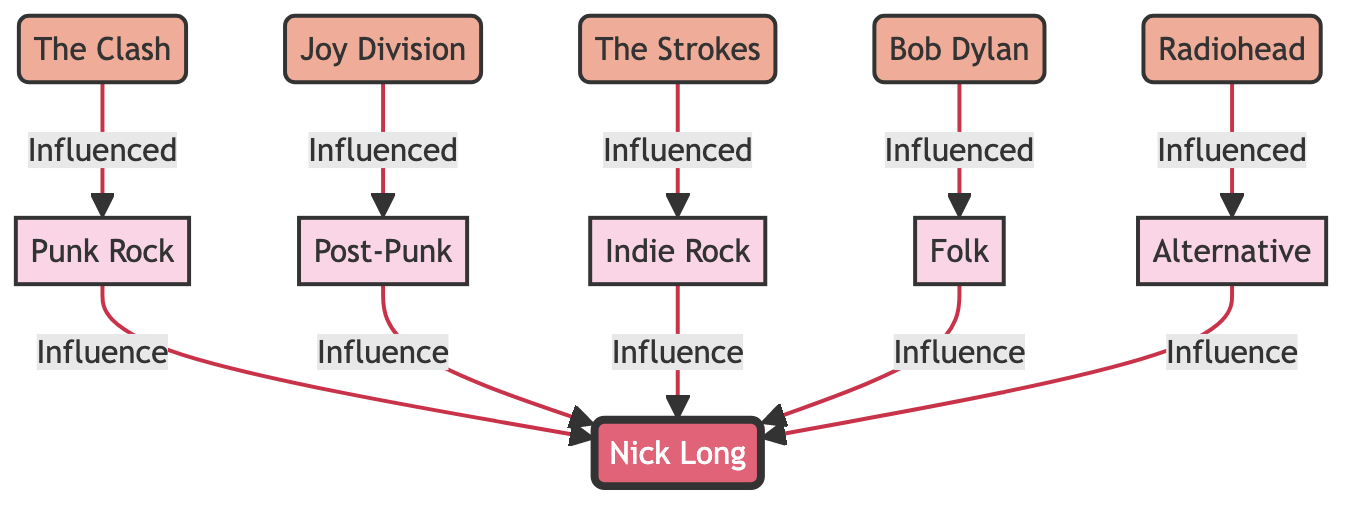What's at the center of the diagram? The center of the diagram is occupied by the node representing Nick Long, which highlights his role as the focal point of the influences discussed.
Answer: Nick Long How many genres are represented in the diagram? By counting the genre nodes, we find Punk Rock, Post-Punk, Indie Rock, Folk, and Alternative, totaling five distinct genres influencing Nick Long's songwriting.
Answer: 5 Which artist influenced the Folk genre? The Folk genre is influenced by Bob Dylan, as indicated by the direct link from Bob Dylan to the Folk node.
Answer: Bob Dylan What genre is directly influenced by Joy Division? Joy Division influences the Post-Punk genre, as shown by the directional arrow flowing from Joy Division to Post-Punk.
Answer: Post-Punk Which artist is linked to Indie Rock? The Strokes is the artist that influences the Indie Rock genre as per the diagram, connecting Indie Rock to The Strokes.
Answer: The Strokes How many artists influence Nick Long's musical style? Observing the diagram, we can see that four distinct artists (The Clash, Joy Division, The Strokes, and Bob Dylan, along with Radiohead indirectly through genres) have a direct influence on Nick Long.
Answer: 4 Which genre is influenced by Radiohead? Radiohead influences the Alternative genre, and this relationship is represented in the diagram with a directional link leading from Radiohead to Alternative.
Answer: Alternative What is the relationship between The Clash and Punk Rock? The diagram displays a directional link where The Clash is indicated as influencing the Punk Rock genre, showing the historical connection of influence.
Answer: Influenced How many total edges (influence relationships) are depicted in the diagram? By counting all the arrows representing influence relationships, there are eight distinct edges connecting various artists and genres to Nick Long.
Answer: 8 